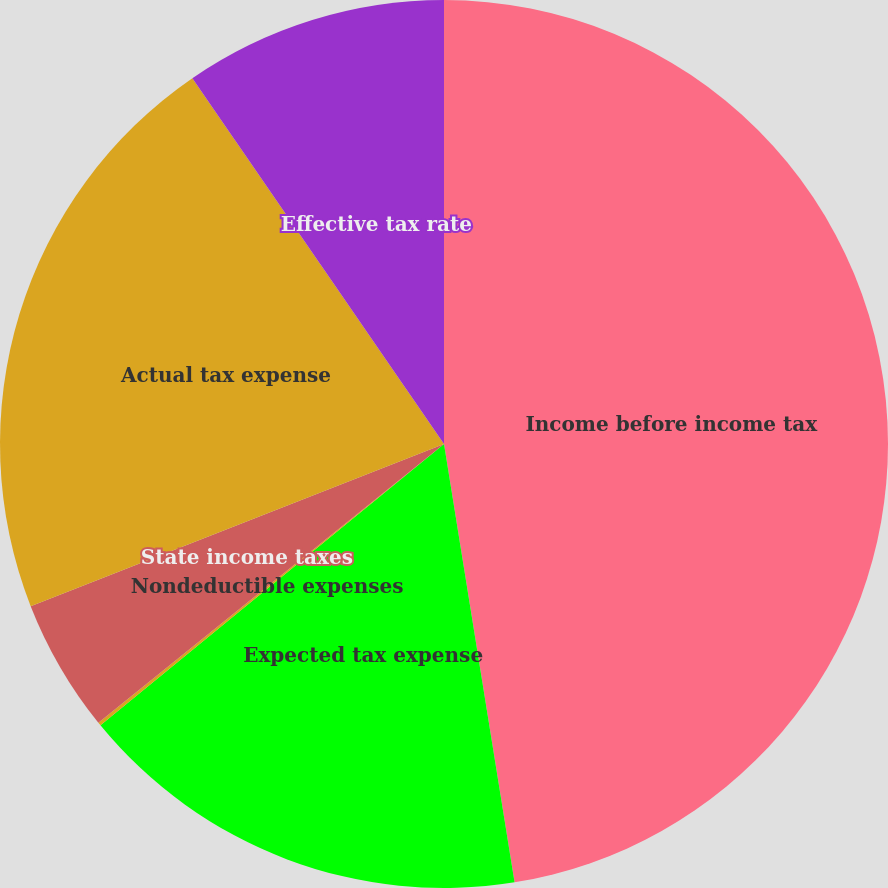Convert chart. <chart><loc_0><loc_0><loc_500><loc_500><pie_chart><fcel>Income before income tax<fcel>Expected tax expense<fcel>Nondeductible expenses<fcel>State income taxes<fcel>Actual tax expense<fcel>Effective tax rate<nl><fcel>47.46%<fcel>16.62%<fcel>0.12%<fcel>4.85%<fcel>21.36%<fcel>9.59%<nl></chart> 